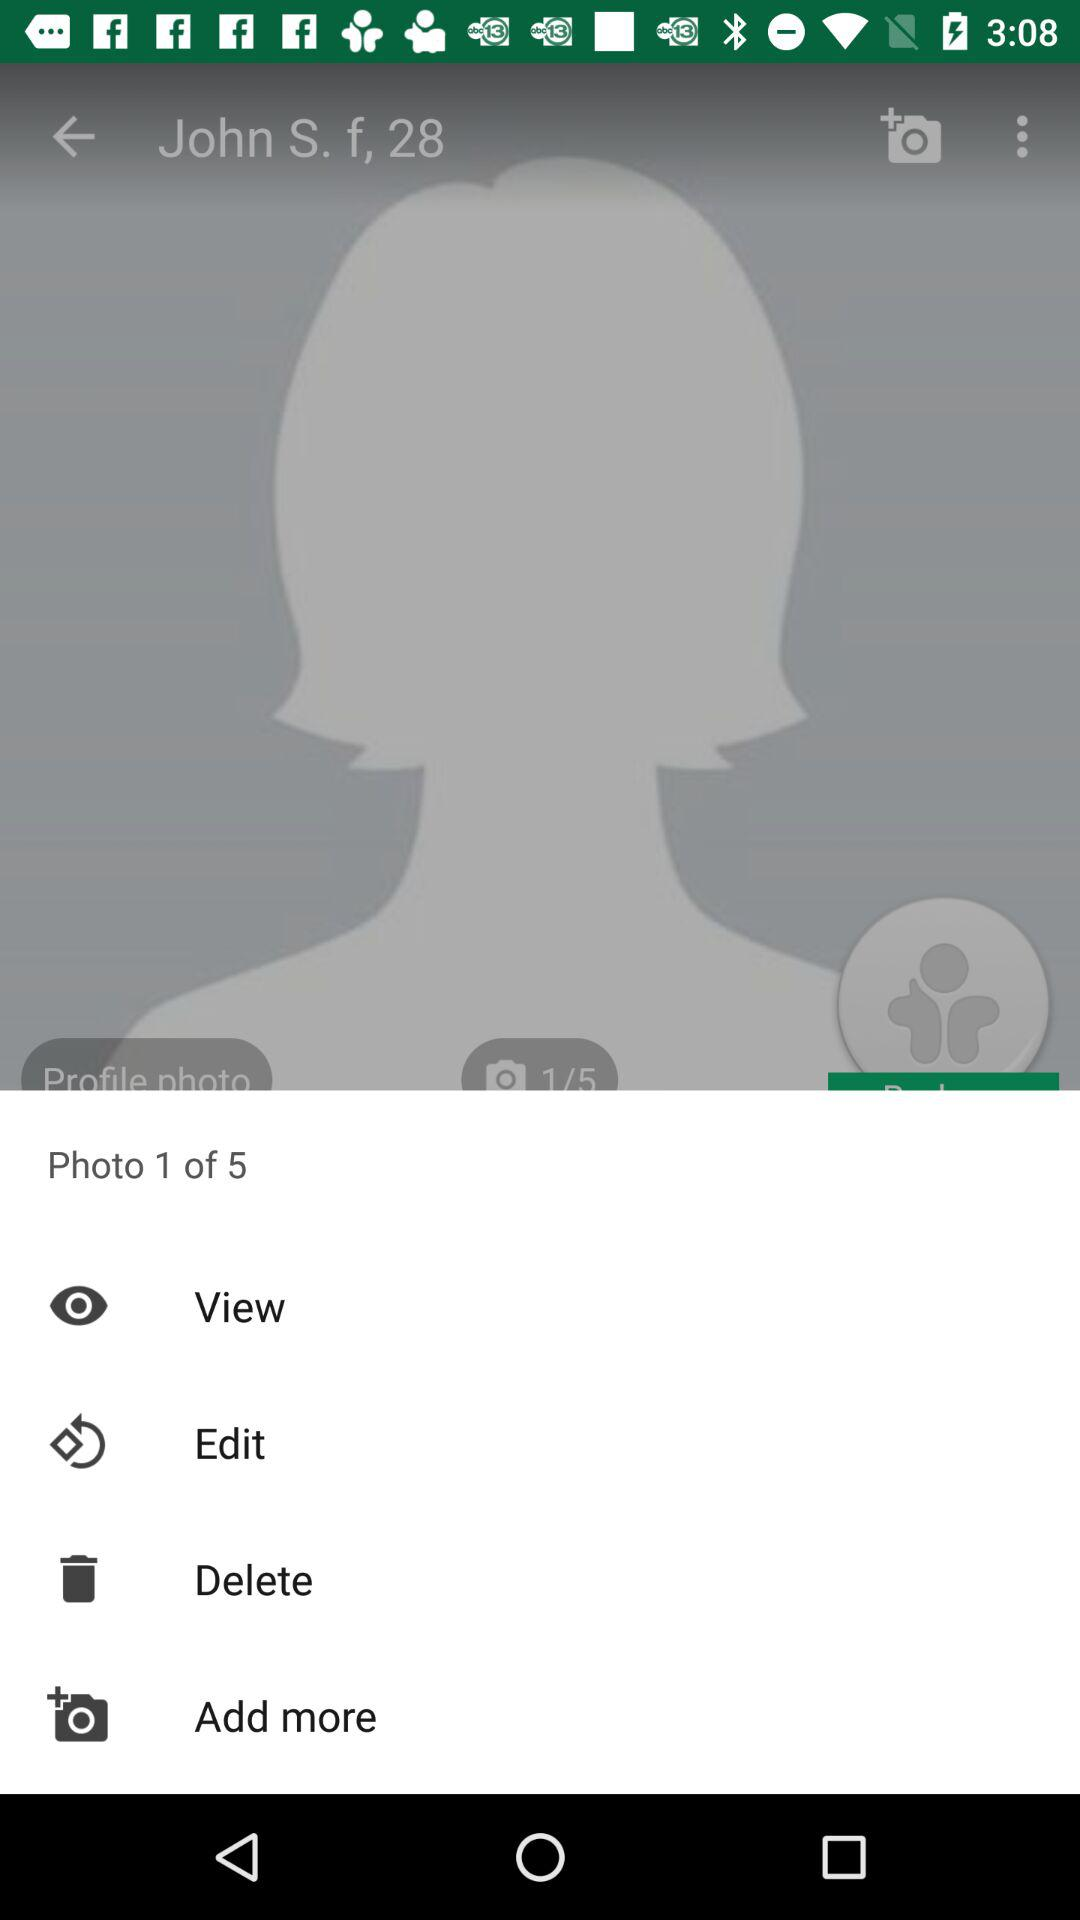At what photo am I? You are on photo 1. 